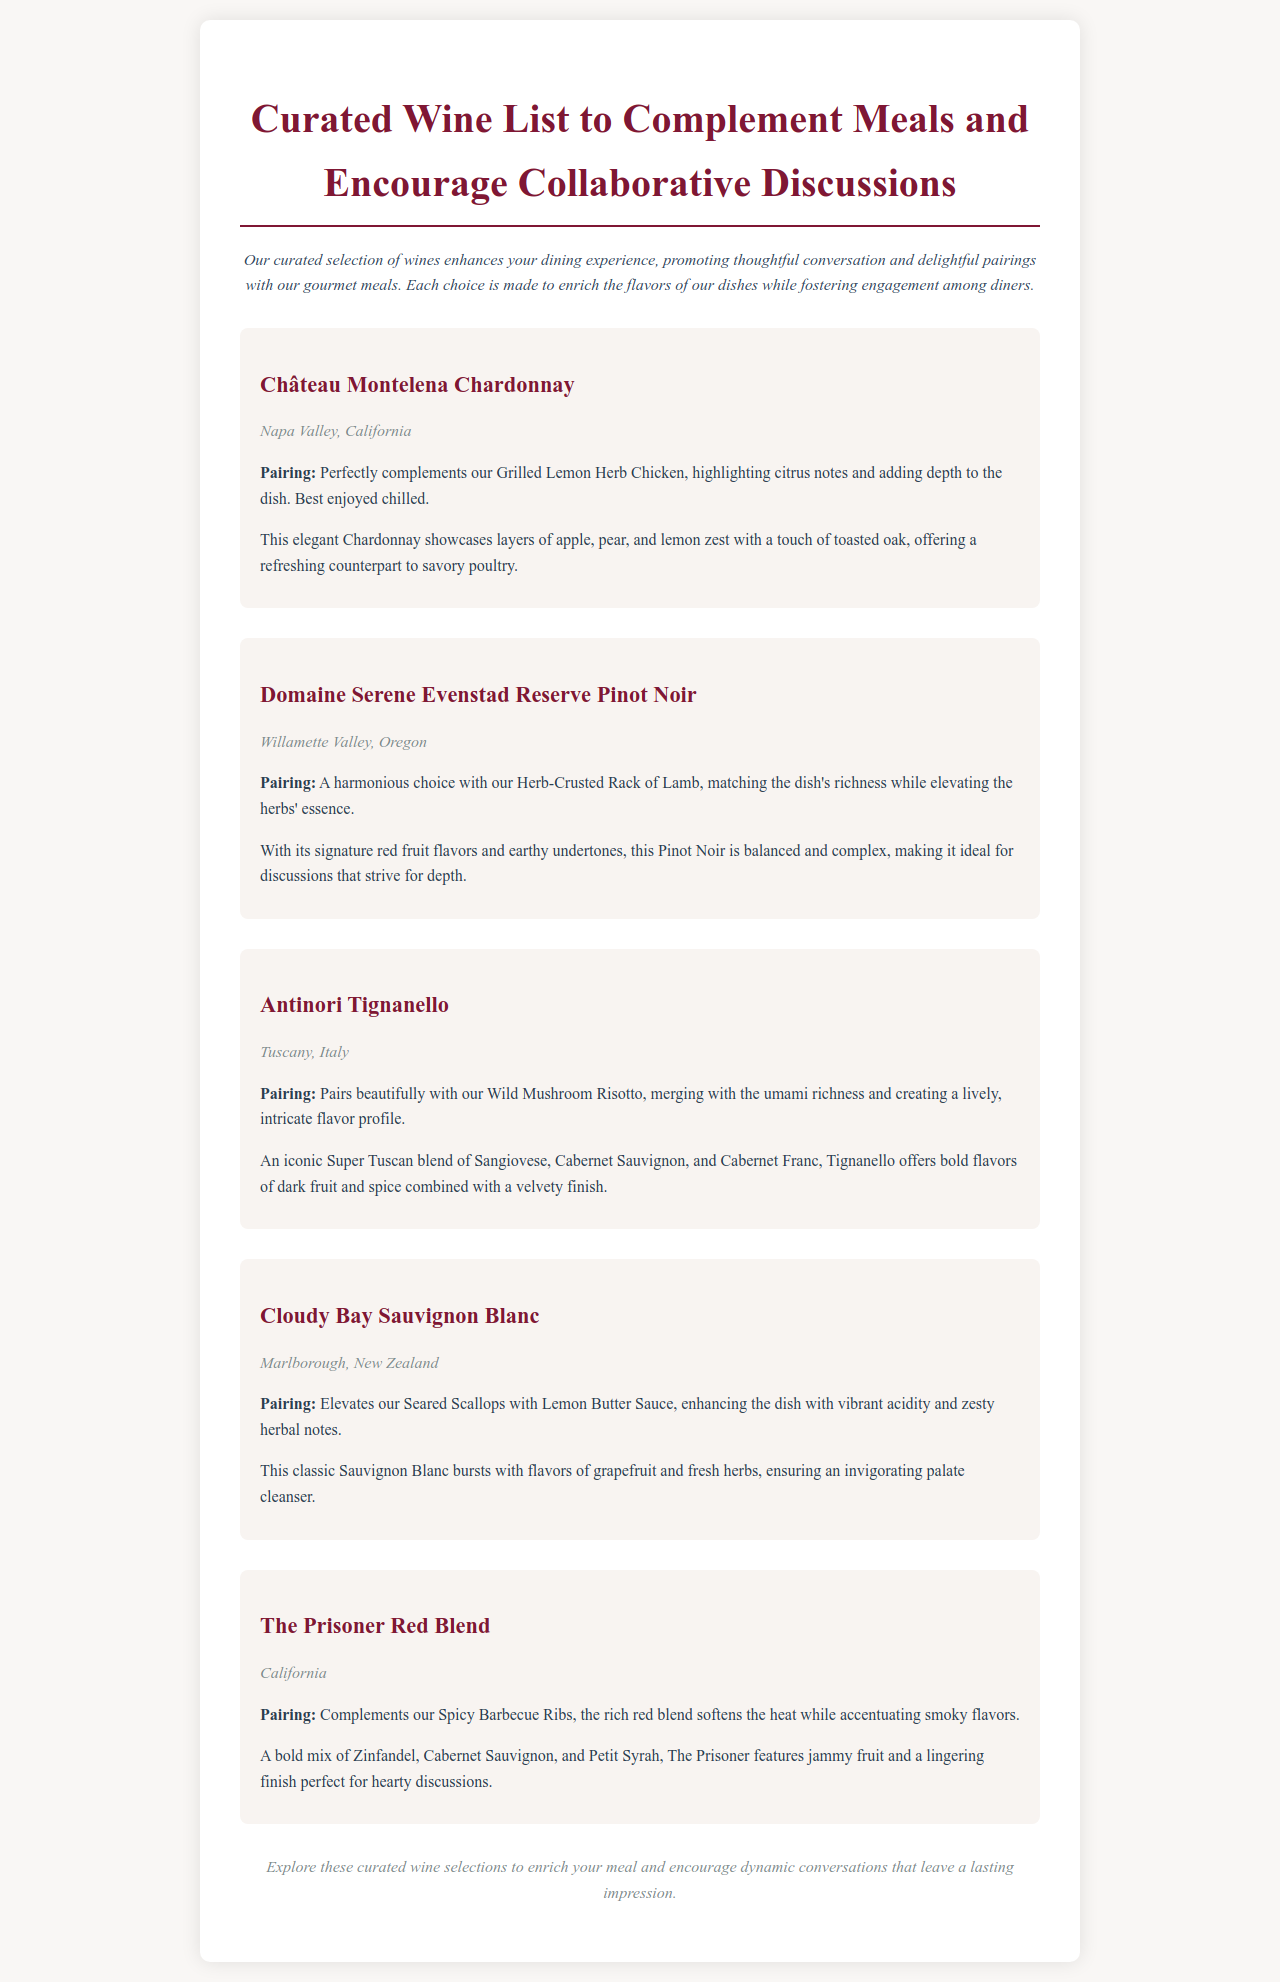What is the title of the document? The title is stated prominently at the top of the document, encapsulating its theme.
Answer: Curated Wine List to Complement Meals and Encourage Collaborative Discussions Which wine pairs with Grilled Lemon Herb Chicken? The pairing information indicates which wine complements specific dishes.
Answer: Château Montelena Chardonnay What region is Château Montelena Chardonnay from? The wine's origin is provided within its description, highlighting its geographical background.
Answer: Napa Valley, California What is the primary flavor profile of Antinori Tignanello? The description of the wine details key flavors that characterize it, aiding in understanding its profile.
Answer: Bold flavors of dark fruit and spice Which wine has a vibrant acidity that complements Seared Scallops? The pairing information helps identify wines that enhance certain dishes through their flavors.
Answer: Cloudy Bay Sauvignon Blanc How many wines are included in the list? The number of wine items is derived from counting the individual entries in the document.
Answer: Five What is the purpose of the curated wine list? The document introduces the wine list's intent to enhance the dining experience.
Answer: To promote thoughtful conversation and delightful pairings with meals Which wine is described as having jammy fruit? The wine descriptions often highlight unique characteristics that make them suitable for certain dishes.
Answer: The Prisoner Red Blend What complementary dish is associated with the Domaine Serene Evenstad Reserve Pinot Noir? The pairing information directly connects each wine with the recommended dish to enhance the flavors.
Answer: Herb-Crusted Rack of Lamb 